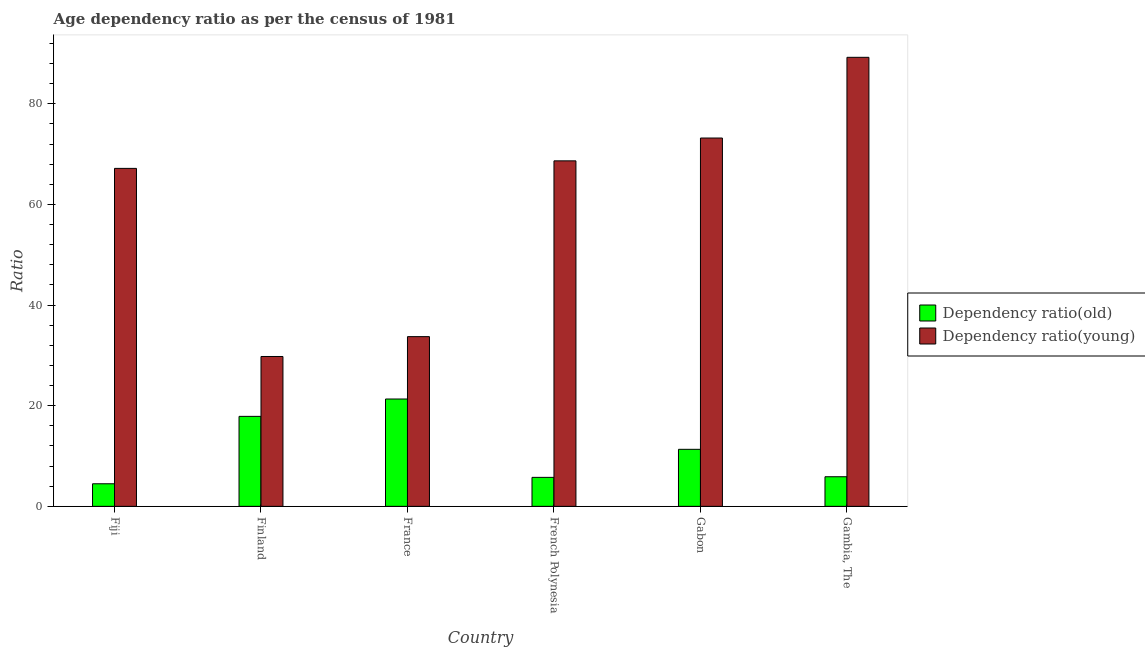How many different coloured bars are there?
Provide a short and direct response. 2. Are the number of bars per tick equal to the number of legend labels?
Offer a terse response. Yes. Are the number of bars on each tick of the X-axis equal?
Make the answer very short. Yes. What is the label of the 6th group of bars from the left?
Offer a terse response. Gambia, The. In how many cases, is the number of bars for a given country not equal to the number of legend labels?
Your answer should be compact. 0. What is the age dependency ratio(young) in Finland?
Your answer should be very brief. 29.78. Across all countries, what is the maximum age dependency ratio(young)?
Provide a succinct answer. 89.24. Across all countries, what is the minimum age dependency ratio(old)?
Offer a terse response. 4.49. In which country was the age dependency ratio(old) minimum?
Your response must be concise. Fiji. What is the total age dependency ratio(old) in the graph?
Keep it short and to the point. 66.68. What is the difference between the age dependency ratio(young) in French Polynesia and that in Gabon?
Provide a succinct answer. -4.54. What is the difference between the age dependency ratio(young) in Gambia, The and the age dependency ratio(old) in France?
Offer a very short reply. 67.91. What is the average age dependency ratio(young) per country?
Provide a short and direct response. 60.3. What is the difference between the age dependency ratio(young) and age dependency ratio(old) in Gabon?
Offer a very short reply. 61.87. What is the ratio of the age dependency ratio(old) in Finland to that in Gabon?
Your answer should be very brief. 1.58. Is the difference between the age dependency ratio(old) in French Polynesia and Gambia, The greater than the difference between the age dependency ratio(young) in French Polynesia and Gambia, The?
Keep it short and to the point. Yes. What is the difference between the highest and the second highest age dependency ratio(old)?
Your answer should be compact. 3.45. What is the difference between the highest and the lowest age dependency ratio(young)?
Provide a short and direct response. 59.46. What does the 1st bar from the left in Gabon represents?
Give a very brief answer. Dependency ratio(old). What does the 2nd bar from the right in Gabon represents?
Your answer should be compact. Dependency ratio(old). Are all the bars in the graph horizontal?
Offer a terse response. No. How many countries are there in the graph?
Make the answer very short. 6. What is the difference between two consecutive major ticks on the Y-axis?
Make the answer very short. 20. Are the values on the major ticks of Y-axis written in scientific E-notation?
Ensure brevity in your answer.  No. Does the graph contain any zero values?
Your response must be concise. No. Does the graph contain grids?
Your answer should be compact. No. What is the title of the graph?
Offer a very short reply. Age dependency ratio as per the census of 1981. Does "Nitrous oxide" appear as one of the legend labels in the graph?
Your response must be concise. No. What is the label or title of the X-axis?
Offer a very short reply. Country. What is the label or title of the Y-axis?
Your response must be concise. Ratio. What is the Ratio in Dependency ratio(old) in Fiji?
Provide a short and direct response. 4.49. What is the Ratio in Dependency ratio(young) in Fiji?
Provide a succinct answer. 67.17. What is the Ratio in Dependency ratio(old) in Finland?
Keep it short and to the point. 17.88. What is the Ratio in Dependency ratio(young) in Finland?
Offer a terse response. 29.78. What is the Ratio in Dependency ratio(old) in France?
Your response must be concise. 21.33. What is the Ratio of Dependency ratio(young) in France?
Provide a succinct answer. 33.73. What is the Ratio in Dependency ratio(old) in French Polynesia?
Provide a succinct answer. 5.76. What is the Ratio of Dependency ratio(young) in French Polynesia?
Your answer should be compact. 68.67. What is the Ratio in Dependency ratio(old) in Gabon?
Keep it short and to the point. 11.33. What is the Ratio of Dependency ratio(young) in Gabon?
Your answer should be compact. 73.2. What is the Ratio in Dependency ratio(old) in Gambia, The?
Your answer should be compact. 5.88. What is the Ratio in Dependency ratio(young) in Gambia, The?
Keep it short and to the point. 89.24. Across all countries, what is the maximum Ratio of Dependency ratio(old)?
Keep it short and to the point. 21.33. Across all countries, what is the maximum Ratio of Dependency ratio(young)?
Provide a succinct answer. 89.24. Across all countries, what is the minimum Ratio of Dependency ratio(old)?
Your answer should be very brief. 4.49. Across all countries, what is the minimum Ratio of Dependency ratio(young)?
Ensure brevity in your answer.  29.78. What is the total Ratio of Dependency ratio(old) in the graph?
Your response must be concise. 66.68. What is the total Ratio in Dependency ratio(young) in the graph?
Offer a very short reply. 361.79. What is the difference between the Ratio in Dependency ratio(old) in Fiji and that in Finland?
Make the answer very short. -13.4. What is the difference between the Ratio of Dependency ratio(young) in Fiji and that in Finland?
Provide a succinct answer. 37.39. What is the difference between the Ratio in Dependency ratio(old) in Fiji and that in France?
Your answer should be compact. -16.85. What is the difference between the Ratio of Dependency ratio(young) in Fiji and that in France?
Make the answer very short. 33.44. What is the difference between the Ratio in Dependency ratio(old) in Fiji and that in French Polynesia?
Ensure brevity in your answer.  -1.27. What is the difference between the Ratio of Dependency ratio(young) in Fiji and that in French Polynesia?
Offer a terse response. -1.5. What is the difference between the Ratio of Dependency ratio(old) in Fiji and that in Gabon?
Your answer should be compact. -6.85. What is the difference between the Ratio in Dependency ratio(young) in Fiji and that in Gabon?
Your answer should be compact. -6.03. What is the difference between the Ratio of Dependency ratio(old) in Fiji and that in Gambia, The?
Provide a succinct answer. -1.4. What is the difference between the Ratio of Dependency ratio(young) in Fiji and that in Gambia, The?
Offer a terse response. -22.07. What is the difference between the Ratio in Dependency ratio(old) in Finland and that in France?
Your answer should be very brief. -3.45. What is the difference between the Ratio in Dependency ratio(young) in Finland and that in France?
Your answer should be compact. -3.95. What is the difference between the Ratio in Dependency ratio(old) in Finland and that in French Polynesia?
Your response must be concise. 12.12. What is the difference between the Ratio in Dependency ratio(young) in Finland and that in French Polynesia?
Your response must be concise. -38.88. What is the difference between the Ratio in Dependency ratio(old) in Finland and that in Gabon?
Ensure brevity in your answer.  6.55. What is the difference between the Ratio of Dependency ratio(young) in Finland and that in Gabon?
Your answer should be very brief. -43.42. What is the difference between the Ratio in Dependency ratio(old) in Finland and that in Gambia, The?
Ensure brevity in your answer.  12. What is the difference between the Ratio in Dependency ratio(young) in Finland and that in Gambia, The?
Offer a terse response. -59.46. What is the difference between the Ratio of Dependency ratio(old) in France and that in French Polynesia?
Provide a succinct answer. 15.57. What is the difference between the Ratio of Dependency ratio(young) in France and that in French Polynesia?
Your answer should be very brief. -34.94. What is the difference between the Ratio of Dependency ratio(old) in France and that in Gabon?
Offer a terse response. 10. What is the difference between the Ratio of Dependency ratio(young) in France and that in Gabon?
Provide a short and direct response. -39.47. What is the difference between the Ratio in Dependency ratio(old) in France and that in Gambia, The?
Offer a terse response. 15.45. What is the difference between the Ratio of Dependency ratio(young) in France and that in Gambia, The?
Make the answer very short. -55.51. What is the difference between the Ratio of Dependency ratio(old) in French Polynesia and that in Gabon?
Provide a succinct answer. -5.57. What is the difference between the Ratio in Dependency ratio(young) in French Polynesia and that in Gabon?
Your response must be concise. -4.54. What is the difference between the Ratio in Dependency ratio(old) in French Polynesia and that in Gambia, The?
Provide a succinct answer. -0.12. What is the difference between the Ratio in Dependency ratio(young) in French Polynesia and that in Gambia, The?
Offer a terse response. -20.57. What is the difference between the Ratio of Dependency ratio(old) in Gabon and that in Gambia, The?
Ensure brevity in your answer.  5.45. What is the difference between the Ratio in Dependency ratio(young) in Gabon and that in Gambia, The?
Give a very brief answer. -16.04. What is the difference between the Ratio of Dependency ratio(old) in Fiji and the Ratio of Dependency ratio(young) in Finland?
Your response must be concise. -25.3. What is the difference between the Ratio in Dependency ratio(old) in Fiji and the Ratio in Dependency ratio(young) in France?
Make the answer very short. -29.24. What is the difference between the Ratio of Dependency ratio(old) in Fiji and the Ratio of Dependency ratio(young) in French Polynesia?
Ensure brevity in your answer.  -64.18. What is the difference between the Ratio in Dependency ratio(old) in Fiji and the Ratio in Dependency ratio(young) in Gabon?
Keep it short and to the point. -68.71. What is the difference between the Ratio in Dependency ratio(old) in Fiji and the Ratio in Dependency ratio(young) in Gambia, The?
Make the answer very short. -84.75. What is the difference between the Ratio in Dependency ratio(old) in Finland and the Ratio in Dependency ratio(young) in France?
Ensure brevity in your answer.  -15.85. What is the difference between the Ratio in Dependency ratio(old) in Finland and the Ratio in Dependency ratio(young) in French Polynesia?
Give a very brief answer. -50.78. What is the difference between the Ratio of Dependency ratio(old) in Finland and the Ratio of Dependency ratio(young) in Gabon?
Ensure brevity in your answer.  -55.32. What is the difference between the Ratio of Dependency ratio(old) in Finland and the Ratio of Dependency ratio(young) in Gambia, The?
Your answer should be compact. -71.36. What is the difference between the Ratio of Dependency ratio(old) in France and the Ratio of Dependency ratio(young) in French Polynesia?
Keep it short and to the point. -47.33. What is the difference between the Ratio in Dependency ratio(old) in France and the Ratio in Dependency ratio(young) in Gabon?
Provide a short and direct response. -51.87. What is the difference between the Ratio of Dependency ratio(old) in France and the Ratio of Dependency ratio(young) in Gambia, The?
Make the answer very short. -67.91. What is the difference between the Ratio in Dependency ratio(old) in French Polynesia and the Ratio in Dependency ratio(young) in Gabon?
Your answer should be very brief. -67.44. What is the difference between the Ratio of Dependency ratio(old) in French Polynesia and the Ratio of Dependency ratio(young) in Gambia, The?
Keep it short and to the point. -83.48. What is the difference between the Ratio in Dependency ratio(old) in Gabon and the Ratio in Dependency ratio(young) in Gambia, The?
Your response must be concise. -77.91. What is the average Ratio in Dependency ratio(old) per country?
Your response must be concise. 11.11. What is the average Ratio of Dependency ratio(young) per country?
Make the answer very short. 60.3. What is the difference between the Ratio of Dependency ratio(old) and Ratio of Dependency ratio(young) in Fiji?
Offer a very short reply. -62.68. What is the difference between the Ratio of Dependency ratio(old) and Ratio of Dependency ratio(young) in Finland?
Provide a succinct answer. -11.9. What is the difference between the Ratio in Dependency ratio(old) and Ratio in Dependency ratio(young) in France?
Offer a very short reply. -12.4. What is the difference between the Ratio of Dependency ratio(old) and Ratio of Dependency ratio(young) in French Polynesia?
Give a very brief answer. -62.91. What is the difference between the Ratio in Dependency ratio(old) and Ratio in Dependency ratio(young) in Gabon?
Offer a very short reply. -61.87. What is the difference between the Ratio in Dependency ratio(old) and Ratio in Dependency ratio(young) in Gambia, The?
Offer a terse response. -83.36. What is the ratio of the Ratio of Dependency ratio(old) in Fiji to that in Finland?
Offer a very short reply. 0.25. What is the ratio of the Ratio in Dependency ratio(young) in Fiji to that in Finland?
Keep it short and to the point. 2.26. What is the ratio of the Ratio in Dependency ratio(old) in Fiji to that in France?
Give a very brief answer. 0.21. What is the ratio of the Ratio in Dependency ratio(young) in Fiji to that in France?
Your response must be concise. 1.99. What is the ratio of the Ratio in Dependency ratio(old) in Fiji to that in French Polynesia?
Give a very brief answer. 0.78. What is the ratio of the Ratio of Dependency ratio(young) in Fiji to that in French Polynesia?
Provide a short and direct response. 0.98. What is the ratio of the Ratio of Dependency ratio(old) in Fiji to that in Gabon?
Provide a short and direct response. 0.4. What is the ratio of the Ratio of Dependency ratio(young) in Fiji to that in Gabon?
Your answer should be very brief. 0.92. What is the ratio of the Ratio in Dependency ratio(old) in Fiji to that in Gambia, The?
Ensure brevity in your answer.  0.76. What is the ratio of the Ratio in Dependency ratio(young) in Fiji to that in Gambia, The?
Provide a short and direct response. 0.75. What is the ratio of the Ratio in Dependency ratio(old) in Finland to that in France?
Your answer should be very brief. 0.84. What is the ratio of the Ratio in Dependency ratio(young) in Finland to that in France?
Provide a succinct answer. 0.88. What is the ratio of the Ratio of Dependency ratio(old) in Finland to that in French Polynesia?
Your answer should be very brief. 3.1. What is the ratio of the Ratio in Dependency ratio(young) in Finland to that in French Polynesia?
Offer a very short reply. 0.43. What is the ratio of the Ratio of Dependency ratio(old) in Finland to that in Gabon?
Make the answer very short. 1.58. What is the ratio of the Ratio of Dependency ratio(young) in Finland to that in Gabon?
Your answer should be very brief. 0.41. What is the ratio of the Ratio of Dependency ratio(old) in Finland to that in Gambia, The?
Ensure brevity in your answer.  3.04. What is the ratio of the Ratio in Dependency ratio(young) in Finland to that in Gambia, The?
Keep it short and to the point. 0.33. What is the ratio of the Ratio in Dependency ratio(old) in France to that in French Polynesia?
Make the answer very short. 3.7. What is the ratio of the Ratio in Dependency ratio(young) in France to that in French Polynesia?
Offer a very short reply. 0.49. What is the ratio of the Ratio of Dependency ratio(old) in France to that in Gabon?
Provide a short and direct response. 1.88. What is the ratio of the Ratio in Dependency ratio(young) in France to that in Gabon?
Provide a short and direct response. 0.46. What is the ratio of the Ratio of Dependency ratio(old) in France to that in Gambia, The?
Your response must be concise. 3.63. What is the ratio of the Ratio of Dependency ratio(young) in France to that in Gambia, The?
Provide a succinct answer. 0.38. What is the ratio of the Ratio in Dependency ratio(old) in French Polynesia to that in Gabon?
Keep it short and to the point. 0.51. What is the ratio of the Ratio in Dependency ratio(young) in French Polynesia to that in Gabon?
Make the answer very short. 0.94. What is the ratio of the Ratio of Dependency ratio(old) in French Polynesia to that in Gambia, The?
Your response must be concise. 0.98. What is the ratio of the Ratio of Dependency ratio(young) in French Polynesia to that in Gambia, The?
Your answer should be compact. 0.77. What is the ratio of the Ratio of Dependency ratio(old) in Gabon to that in Gambia, The?
Your response must be concise. 1.93. What is the ratio of the Ratio of Dependency ratio(young) in Gabon to that in Gambia, The?
Keep it short and to the point. 0.82. What is the difference between the highest and the second highest Ratio in Dependency ratio(old)?
Your answer should be very brief. 3.45. What is the difference between the highest and the second highest Ratio in Dependency ratio(young)?
Your answer should be compact. 16.04. What is the difference between the highest and the lowest Ratio in Dependency ratio(old)?
Keep it short and to the point. 16.85. What is the difference between the highest and the lowest Ratio in Dependency ratio(young)?
Your response must be concise. 59.46. 